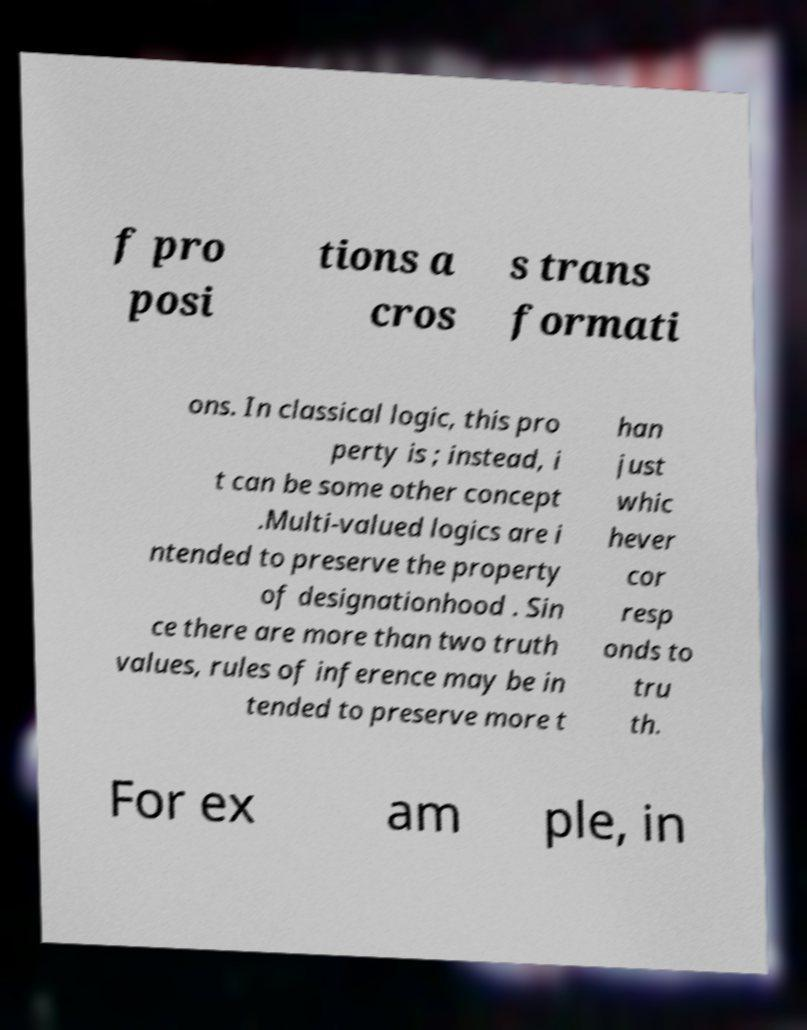What messages or text are displayed in this image? I need them in a readable, typed format. f pro posi tions a cros s trans formati ons. In classical logic, this pro perty is ; instead, i t can be some other concept .Multi-valued logics are i ntended to preserve the property of designationhood . Sin ce there are more than two truth values, rules of inference may be in tended to preserve more t han just whic hever cor resp onds to tru th. For ex am ple, in 